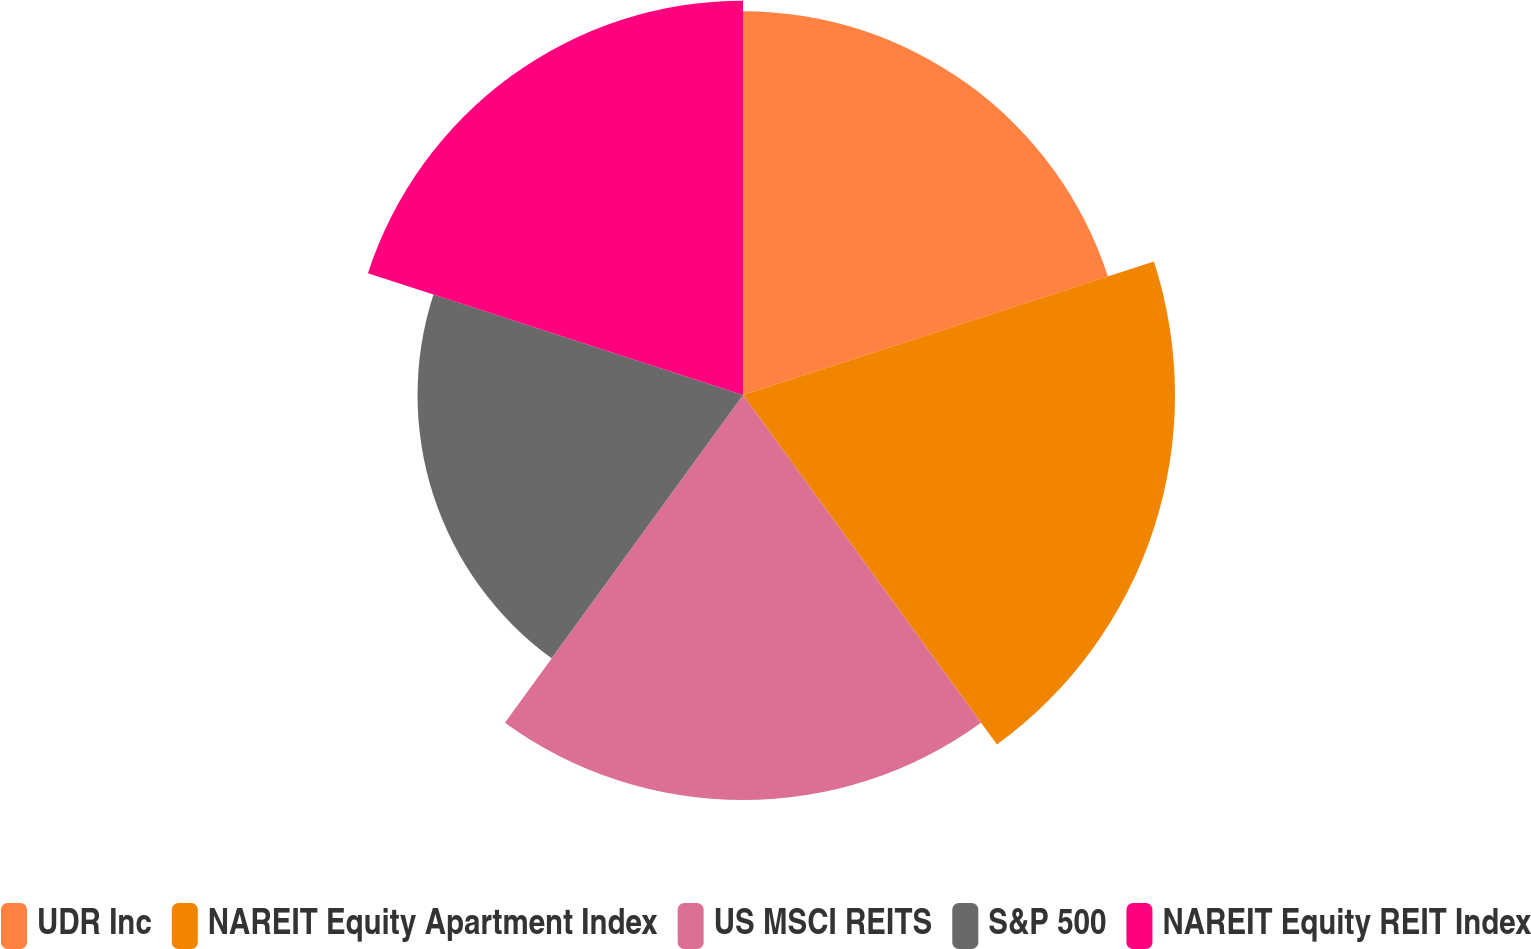Convert chart. <chart><loc_0><loc_0><loc_500><loc_500><pie_chart><fcel>UDR Inc<fcel>NAREIT Equity Apartment Index<fcel>US MSCI REITS<fcel>S&P 500<fcel>NAREIT Equity REIT Index<nl><fcel>19.77%<fcel>22.26%<fcel>20.87%<fcel>16.77%<fcel>20.32%<nl></chart> 